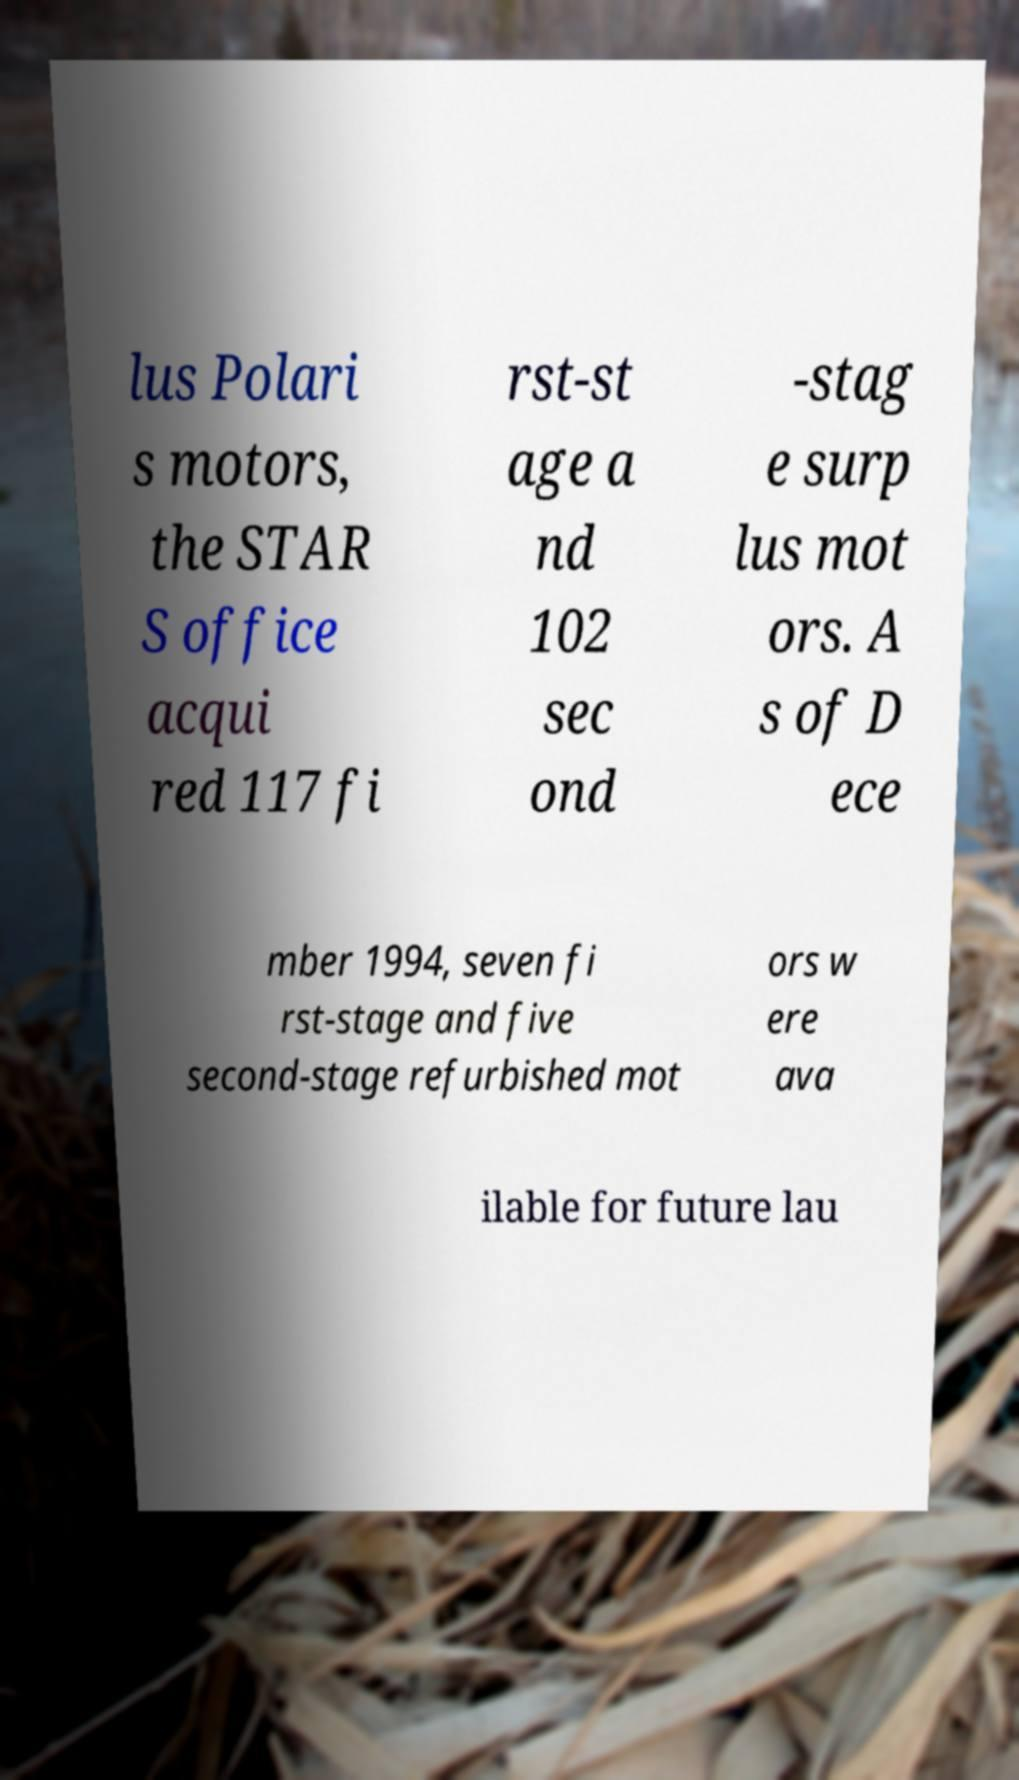Can you accurately transcribe the text from the provided image for me? lus Polari s motors, the STAR S office acqui red 117 fi rst-st age a nd 102 sec ond -stag e surp lus mot ors. A s of D ece mber 1994, seven fi rst-stage and five second-stage refurbished mot ors w ere ava ilable for future lau 